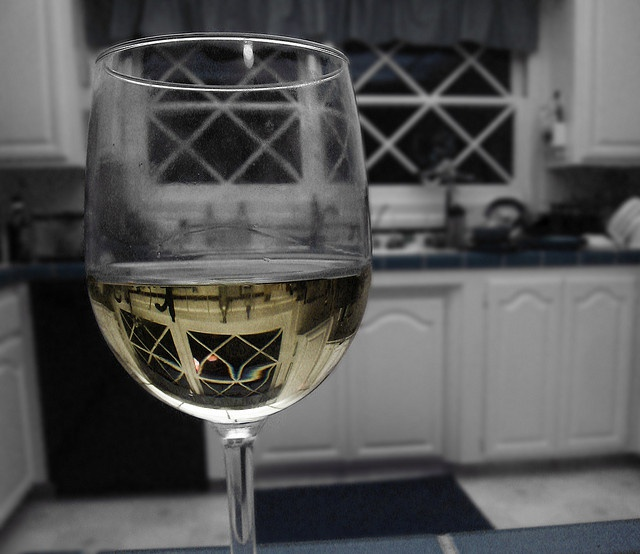Describe the objects in this image and their specific colors. I can see wine glass in gray, black, and tan tones, sink in black and gray tones, book in gray and black tones, bottle in gray and black tones, and sink in gray and black tones in this image. 